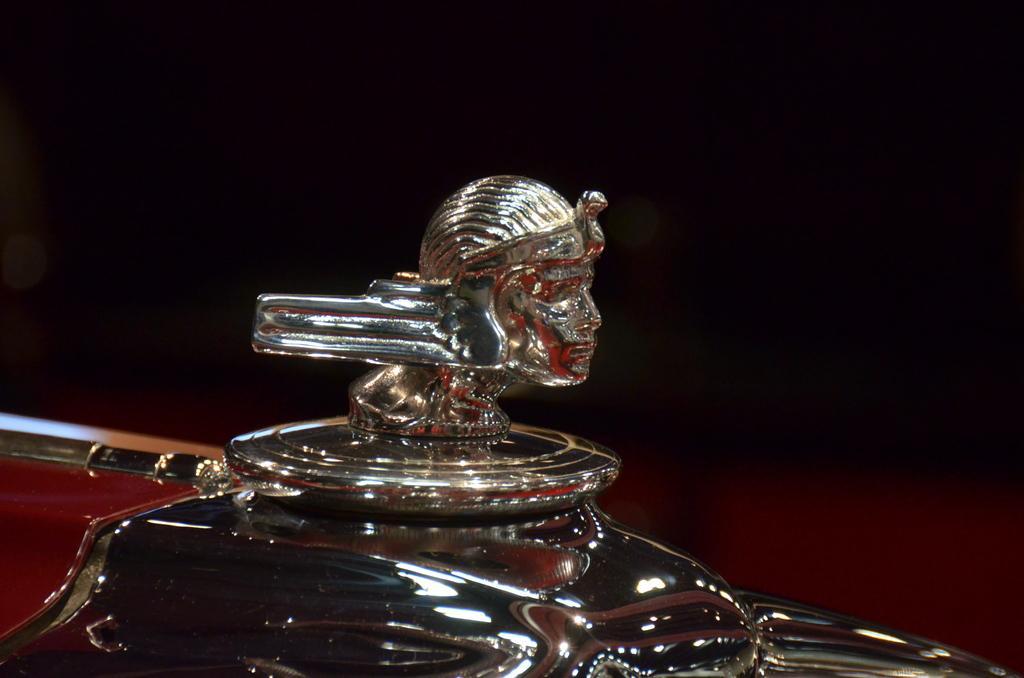Please provide a concise description of this image. It seems to be a part of a vehicle. In the middle of the image there is an idol of a person's face. I is a metal object. The background is dark. 